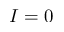Convert formula to latex. <formula><loc_0><loc_0><loc_500><loc_500>I = 0</formula> 